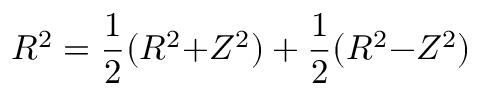<formula> <loc_0><loc_0><loc_500><loc_500>R ^ { 2 } = \frac { 1 } { 2 } ( R ^ { 2 } { + } Z ^ { 2 } ) + \frac { 1 } { 2 } ( R ^ { 2 } { - } Z ^ { 2 } )</formula> 